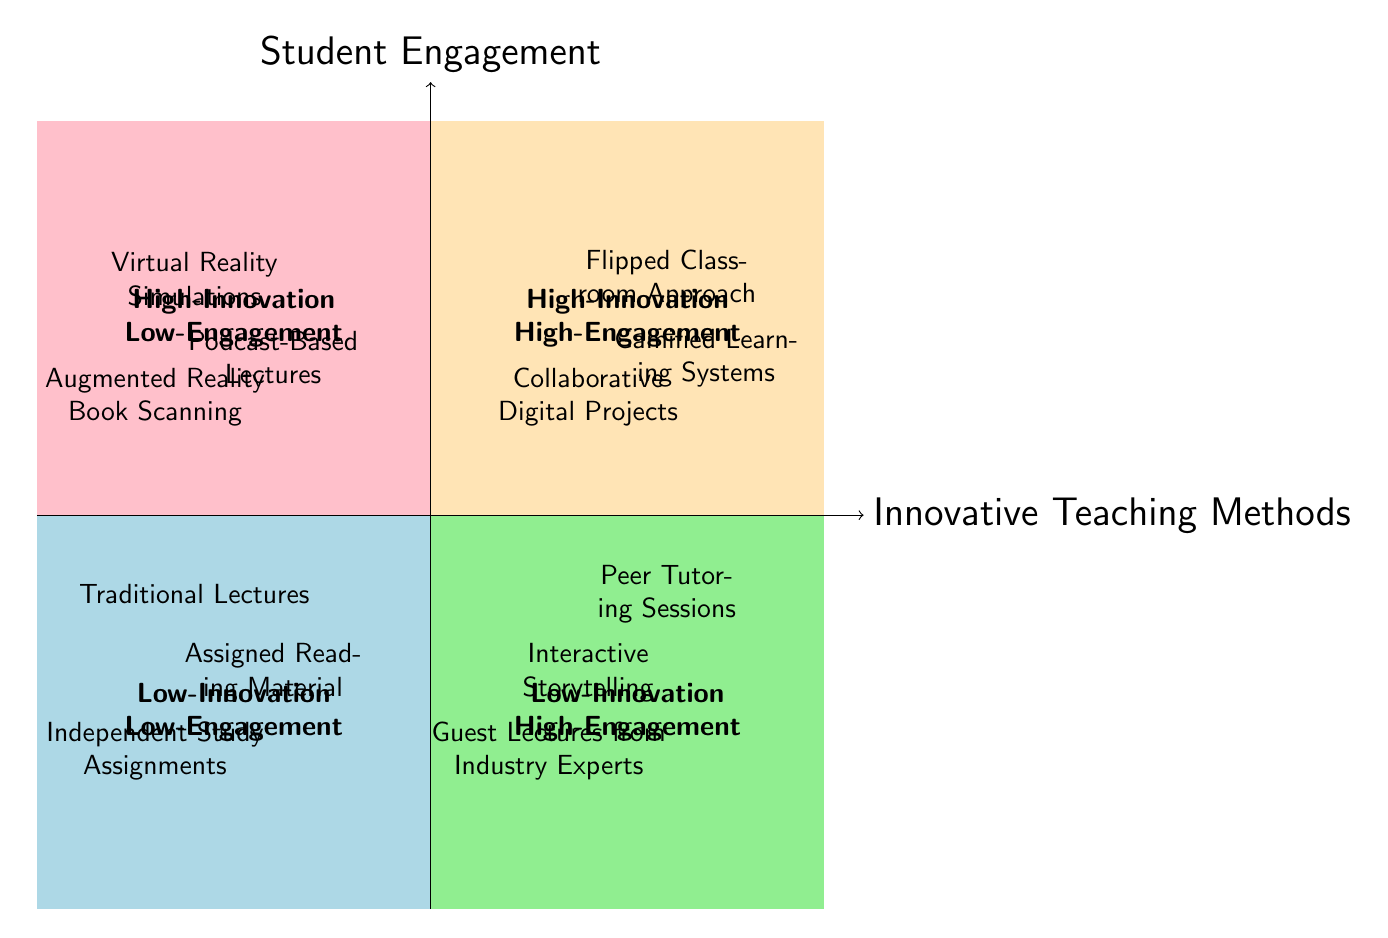What are the three teaching methods in the High-Innovation High-Engagement quadrant? The question asks specifically for the names of the teaching methods positioned in the High-Innovation High-Engagement quadrant. By looking at the diagram, these methods are clearly labeled and can be directly listed.
Answer: Flipped Classroom Approach, Collaborative Digital Projects, Gamified Learning Systems Which quadrant contains Traditional Lectures? This question requires identifying which specific quadrant the method 'Traditional Lectures' is located in. By observing the diagram, Traditional Lectures are found in the Low-Innovation Low-Engagement quadrant.
Answer: Low-Innovation Low-Engagement How many teaching methods are in the Low-Innovation High-Engagement quadrant? The question requires counting the number of teaching methods in the Low-Innovation High-Engagement quadrant. Analyzing the diagram, there are three methods listed in that quadrant.
Answer: 3 Are there any teaching methods with High-Innovation and Low-Engagement? The question looks for the presence of any teaching methods fitting the described criteria. The diagram lists three methods in the High-Innovation Low-Engagement quadrant, so the answer can easily be verified.
Answer: Yes What is the relationship between Gamified Learning Systems and Student Engagement? This question seeks to understand the position of 'Gamified Learning Systems' in relation to Student Engagement. The diagram places it in the High-Innovation High-Engagement quadrant, indicating a positive relationship.
Answer: Positive relationship Which quadrant has the least engagement? This question asks to identify which quadrant reflects the least student engagement, referring to both axes of the quadrant chart. The Low-Innovation Low-Engagement quadrant represents the least engagement by being in the lowest part of the chart.
Answer: Low-Innovation Low-Engagement Which teaching method is the outlier in terms of High-Innovation but Low-Engagement? The question is about recognizing a teaching method that stands out for being innovative yet not engaging. From the diagram, Virtual Reality Simulations is placed in the High-Innovation Low-Engagement quadrant, hence serving as an outlier.
Answer: Virtual Reality Simulations What teaching methods are listed in the Low-Innovation High-Engagement quadrant? This question seeks the specific methods located in the Low-Innovation High-Engagement quadrant. Directly inspecting the diagram reveals three specific teaching methods mentioned there.
Answer: Interactive Storytelling, Peer Tutoring Sessions, Guest Lectures from Industry Experts Identify an innovative method that does not engage students well. This question leads to identifying an example from the High-Innovation Low-Engagement quadrant, forcing the responder to navigate toward methods that fulfill both criteria. Augmented Reality Book Scanning fits this category according to the chart.
Answer: Augmented Reality Book Scanning 